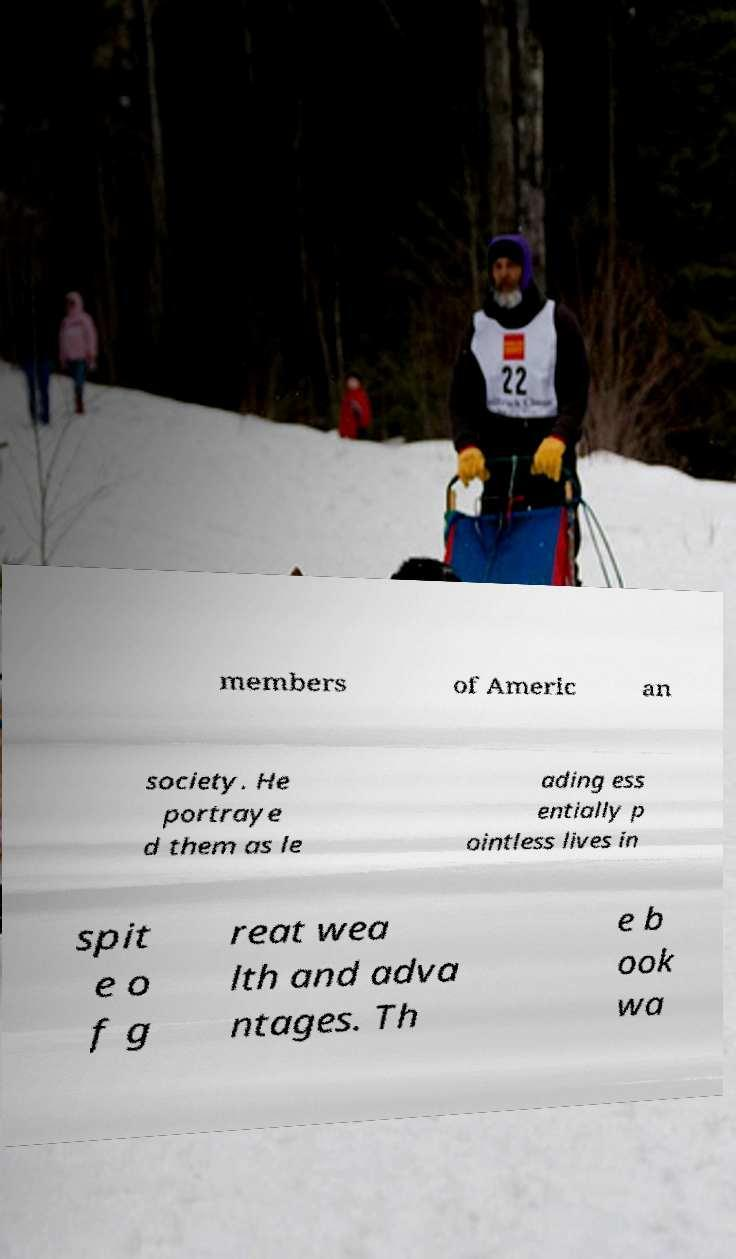Can you accurately transcribe the text from the provided image for me? members of Americ an society. He portraye d them as le ading ess entially p ointless lives in spit e o f g reat wea lth and adva ntages. Th e b ook wa 